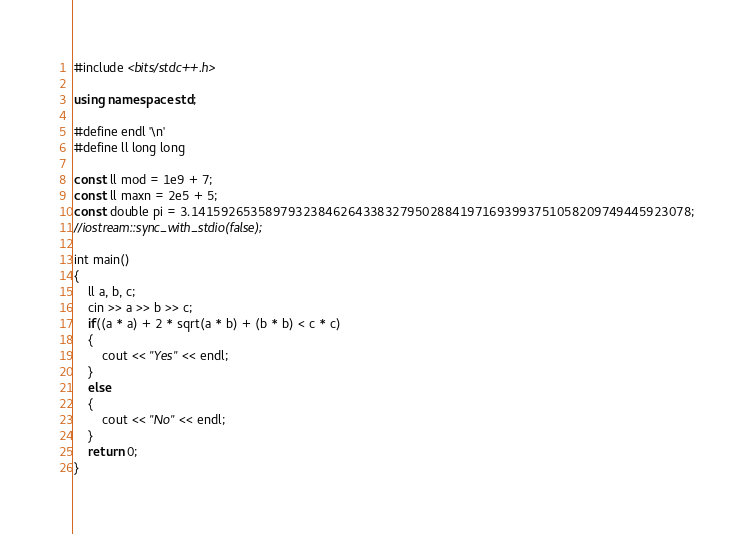<code> <loc_0><loc_0><loc_500><loc_500><_C++_>#include <bits/stdc++.h>

using namespace std;

#define endl '\n'
#define ll long long

const ll mod = 1e9 + 7;
const ll maxn = 2e5 + 5;
const double pi = 3.1415926535897932384626433832795028841971693993751058209749445923078;
//iostream::sync_with_stdio(false);

int main()
{
    ll a, b, c;
    cin >> a >> b >> c;
    if((a * a) + 2 * sqrt(a * b) + (b * b) < c * c)
    {
        cout << "Yes" << endl;
    }
    else
    {
        cout << "No" << endl;
    }
    return 0;
}
</code> 